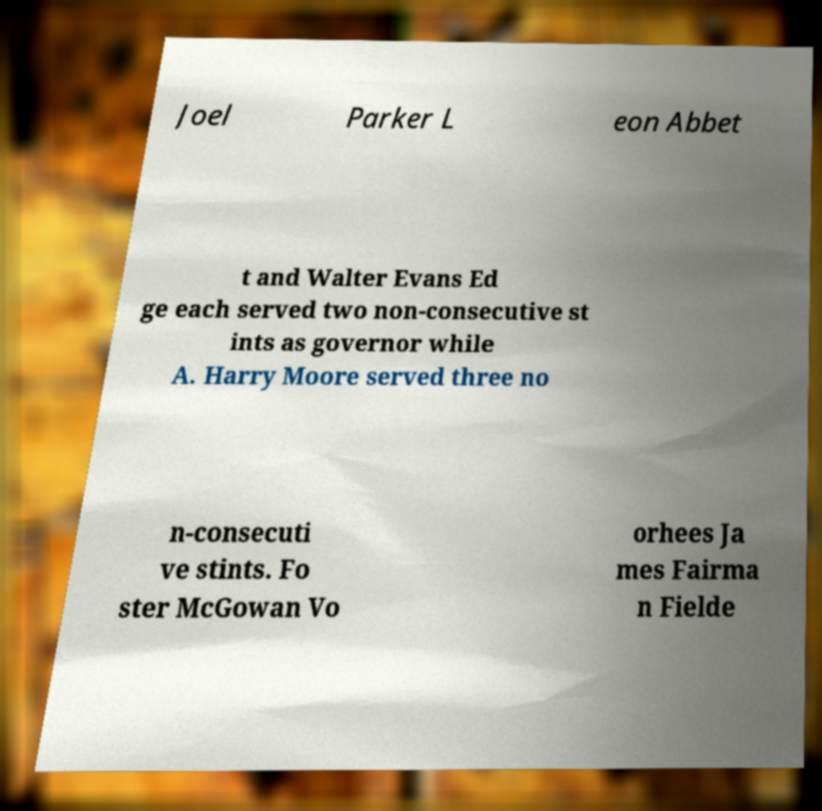Please identify and transcribe the text found in this image. Joel Parker L eon Abbet t and Walter Evans Ed ge each served two non-consecutive st ints as governor while A. Harry Moore served three no n-consecuti ve stints. Fo ster McGowan Vo orhees Ja mes Fairma n Fielde 